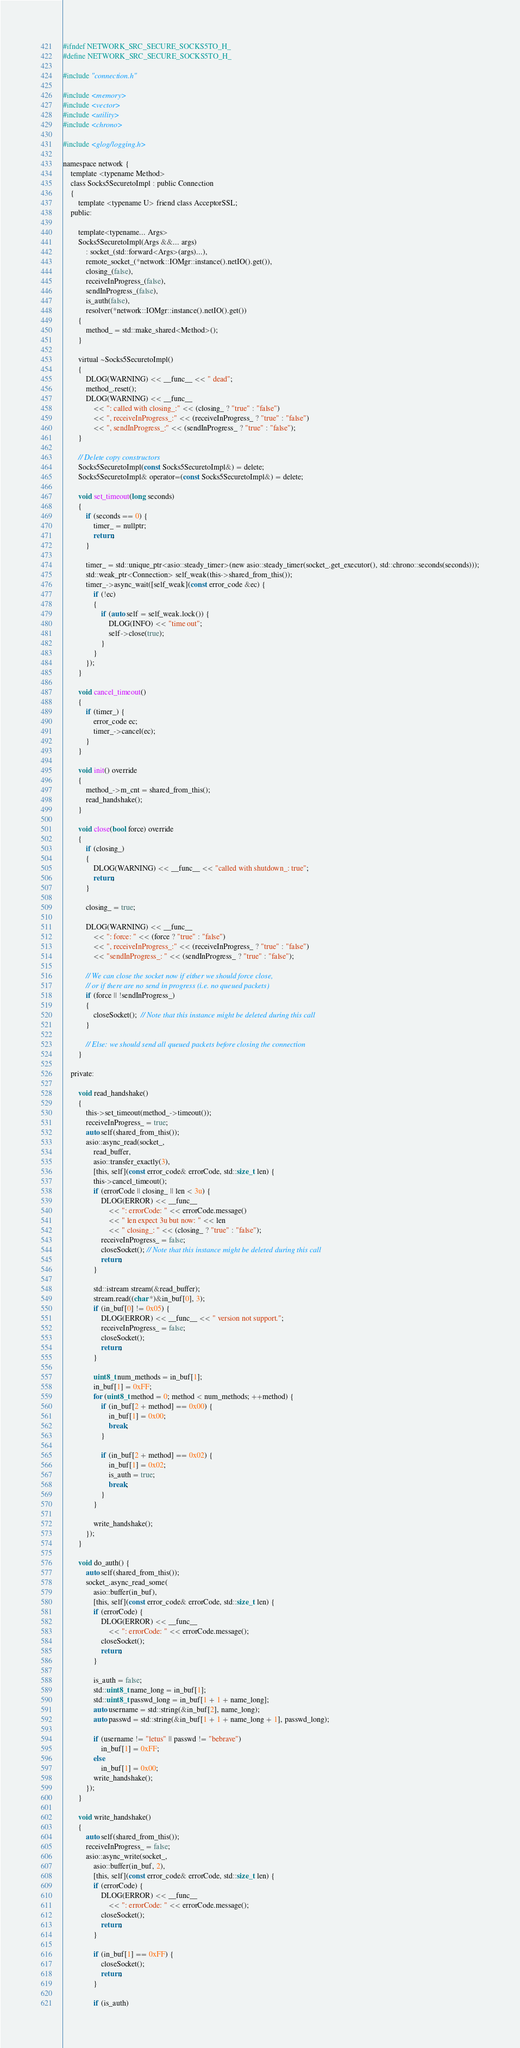Convert code to text. <code><loc_0><loc_0><loc_500><loc_500><_C_>#ifndef NETWORK_SRC_SECURE_SOCKS5TO_H_
#define NETWORK_SRC_SECURE_SOCKS5TO_H_

#include "connection.h"

#include <memory>
#include <vector>
#include <utility>
#include <chrono>

#include <glog/logging.h>

namespace network {
	template <typename Method>
	class Socks5SecuretoImpl : public Connection
	{
		template <typename U> friend class AcceptorSSL;
	public:

		template<typename... Args>
		Socks5SecuretoImpl(Args &&... args)
			: socket_(std::forward<Args>(args)...),
			remote_socket_(*network::IOMgr::instance().netIO().get()),
			closing_(false),
			receiveInProgress_(false),
			sendInProgress_(false),
			is_auth(false),
			resolver(*network::IOMgr::instance().netIO().get())
		{
			method_ = std::make_shared<Method>();
		}

		virtual ~Socks5SecuretoImpl()
		{
			DLOG(WARNING) << __func__ << " dead";
			method_.reset();
			DLOG(WARNING) << __func__
				<< ": called with closing_:" << (closing_ ? "true" : "false")
				<< ", receiveInProgress_:" << (receiveInProgress_ ? "true" : "false")
				<< ", sendInProgress_:" << (sendInProgress_ ? "true" : "false");
		}

		// Delete copy constructors
		Socks5SecuretoImpl(const Socks5SecuretoImpl&) = delete;
		Socks5SecuretoImpl& operator=(const Socks5SecuretoImpl&) = delete;

		void set_timeout(long seconds)
		{
			if (seconds == 0) {
				timer_ = nullptr;
				return;
			}

			timer_ = std::unique_ptr<asio::steady_timer>(new asio::steady_timer(socket_.get_executor(), std::chrono::seconds(seconds)));
			std::weak_ptr<Connection> self_weak(this->shared_from_this());
			timer_->async_wait([self_weak](const error_code &ec) {
				if (!ec)
				{
					if (auto self = self_weak.lock()) {
						DLOG(INFO) << "time out";
						self->close(true);
					}
				}
			});
		}

		void cancel_timeout()
		{
			if (timer_) {
				error_code ec;
				timer_->cancel(ec);
			}
		}

		void init() override
		{
			method_->m_cnt = shared_from_this();
			read_handshake();
		}

		void close(bool force) override
		{
			if (closing_)
			{
				DLOG(WARNING) << __func__ << "called with shutdown_: true";
				return;
			}

			closing_ = true;

			DLOG(WARNING) << __func__
				<< ": force: " << (force ? "true" : "false")
				<< ", receiveInProgress_:" << (receiveInProgress_ ? "true" : "false")
				<< "sendInProgress_: " << (sendInProgress_ ? "true" : "false");

			// We can close the socket now if either we should force close,
			// or if there are no send in progress (i.e. no queued packets)
			if (force || !sendInProgress_)
			{
				closeSocket();  // Note that this instance might be deleted during this call
			}

			// Else: we should send all queued packets before closing the connection
		}

	private:

		void read_handshake()
		{
			this->set_timeout(method_->timeout());
			receiveInProgress_ = true;
			auto self(shared_from_this());
			asio::async_read(socket_,
				read_buffer,
				asio::transfer_exactly(3),
				[this, self](const error_code& errorCode, std::size_t len) {
				this->cancel_timeout();
				if (errorCode || closing_ || len < 3u) {
					DLOG(ERROR) << __func__
						<< ": errorCode: " << errorCode.message()
						<< " len expect 3u but now: " << len
						<< " closing_: " << (closing_ ? "true" : "false");
					receiveInProgress_ = false;
					closeSocket(); // Note that this instance might be deleted during this call
					return;
				}

				std::istream stream(&read_buffer);
				stream.read((char *)&in_buf[0], 3);
				if (in_buf[0] != 0x05) {
					DLOG(ERROR) << __func__ << " version not support.";
					receiveInProgress_ = false;
					closeSocket();
					return;
				}

				uint8_t num_methods = in_buf[1];
				in_buf[1] = 0xFF;
				for (uint8_t method = 0; method < num_methods; ++method) {
					if (in_buf[2 + method] == 0x00) {
						in_buf[1] = 0x00;
						break;
					}

					if (in_buf[2 + method] == 0x02) {
						in_buf[1] = 0x02;
						is_auth = true;
						break;
					}
				}

				write_handshake();
			});
		}

		void do_auth() {
			auto self(shared_from_this());
			socket_.async_read_some(
				asio::buffer(in_buf),
				[this, self](const error_code& errorCode, std::size_t len) {
				if (errorCode) {
					DLOG(ERROR) << __func__
						<< ": errorCode: " << errorCode.message();
					closeSocket();
					return;
				}

				is_auth = false;
				std::uint8_t name_long = in_buf[1];
				std::uint8_t passwd_long = in_buf[1 + 1 + name_long];
				auto username = std::string(&in_buf[2], name_long);
				auto passwd = std::string(&in_buf[1 + 1 + name_long + 1], passwd_long);

				if (username != "letus" || passwd != "bebrave")
					in_buf[1] = 0xFF;
				else
					in_buf[1] = 0x00;
				write_handshake();
			});
		}

		void write_handshake()
		{
			auto self(shared_from_this());
			receiveInProgress_ = false;
			asio::async_write(socket_,
				asio::buffer(in_buf, 2),
				[this, self](const error_code& errorCode, std::size_t len) {
				if (errorCode) {
					DLOG(ERROR) << __func__
						<< ": errorCode: " << errorCode.message();
					closeSocket();
					return;
				}

				if (in_buf[1] == 0xFF) {
					closeSocket();
					return;
				}

				if (is_auth)</code> 